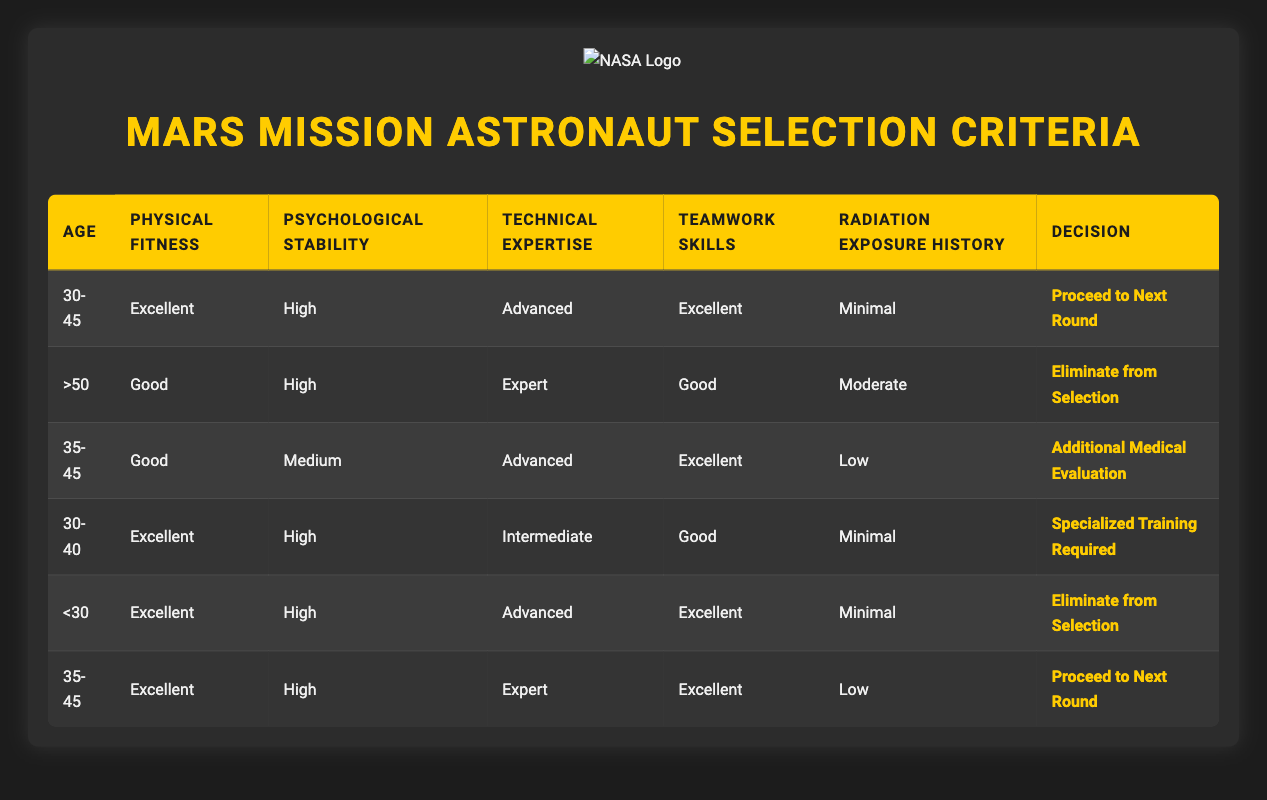What is the decision for an astronaut aged 30-45 with excellent physical fitness and high psychological stability? According to the table, an astronaut in this age range with excellent physical fitness and high psychological stability also has advanced technical expertise and excellent teamwork skills with minimal radiation exposure history. The decision made for this profile is to proceed to the next round.
Answer: Proceed to Next Round What is the decision for an astronaut aged over 50 with good physical fitness? The table specifies that an astronaut aged over 50 with good physical fitness, high psychological stability, expert technical expertise, good teamwork skills, and moderate radiation exposure history will be eliminated from selection.
Answer: Eliminate from Selection How many unique decisions are there listed in the table? The table contains three unique decisions: "Proceed to Next Round," "Eliminate from Selection," and "Additional Medical Evaluation." It shows a total of six rows but has three unique outcomes.
Answer: 3 Is an astronaut aged below 30 with excellent physical fitness and advanced technical expertise eliminated from selection? Yes, according to the table, an astronaut aged below 30, regardless of excellent physical fitness and advanced technical expertise, is flagged to be eliminated from selection.
Answer: Yes For astronauts aged 35-45, how many are approved to proceed to the next round? The table shows two astronauts aged 35-45. Only one of them with excellent physical fitness and high psychological stability qualified to proceed to the next round; the other requires additional medical evaluation.
Answer: 1 What is the average age of astronauts that need additional medical evaluations? There is one astronaut aged 35-45 requiring additional medical evaluation. The average age is simply 35. The astronaut’s age is the only data point here.
Answer: 35 Are all astronauts with excellent physical fitness also proceeding to the next round? No, not all astronauts with excellent physical fitness are proceeding. While some like those aged 30-45 do proceed, others like those aged 30-40 with excellent physical fitness require specialized training.
Answer: No What is the combined total of astronauts that have been eliminated and those that require specialized training? The table has two astronauts who have been eliminated (one aged over 50 and one below 30). Additionally, there’s one astronaut aged 30-40 requiring specialized training. So the total is 2 + 1 = 3.
Answer: 3 What conditions must an astronaut aged 35-45 meet to proceed to the next round? An astronaut in this age group must have excellent physical fitness, high psychological stability, expert technical expertise, excellent teamwork skills, and low radiation exposure history to proceed to the next round.
Answer: Excellent physical fitness, high psychological stability, expert technical expertise, excellent teamwork skills, low radiation exposure history 